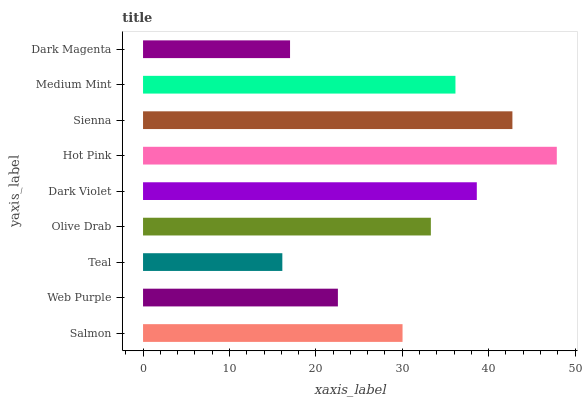Is Teal the minimum?
Answer yes or no. Yes. Is Hot Pink the maximum?
Answer yes or no. Yes. Is Web Purple the minimum?
Answer yes or no. No. Is Web Purple the maximum?
Answer yes or no. No. Is Salmon greater than Web Purple?
Answer yes or no. Yes. Is Web Purple less than Salmon?
Answer yes or no. Yes. Is Web Purple greater than Salmon?
Answer yes or no. No. Is Salmon less than Web Purple?
Answer yes or no. No. Is Olive Drab the high median?
Answer yes or no. Yes. Is Olive Drab the low median?
Answer yes or no. Yes. Is Hot Pink the high median?
Answer yes or no. No. Is Medium Mint the low median?
Answer yes or no. No. 